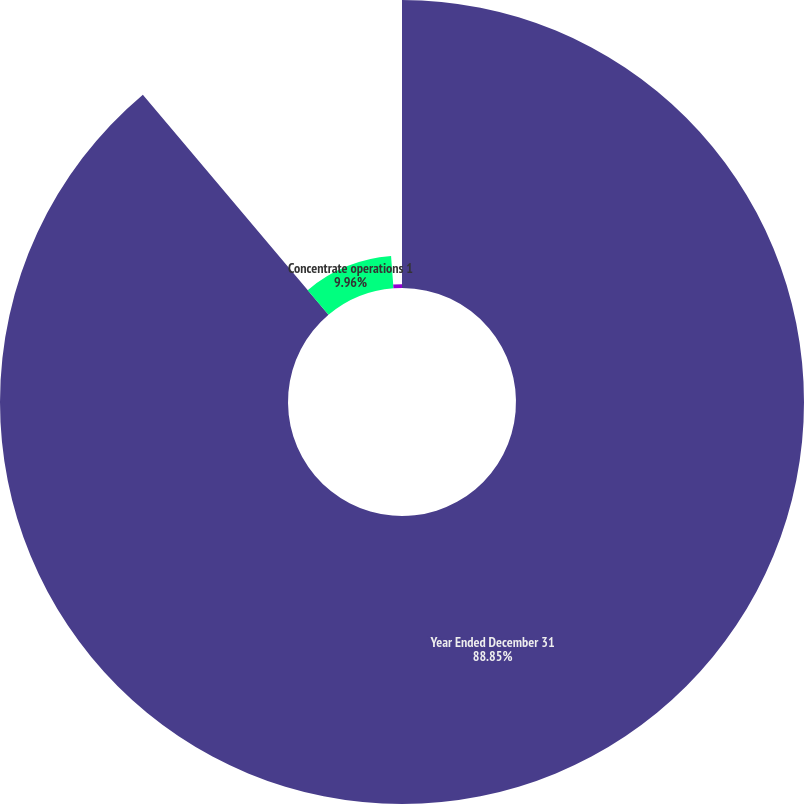Convert chart to OTSL. <chart><loc_0><loc_0><loc_500><loc_500><pie_chart><fcel>Year Ended December 31<fcel>Concentrate operations 1<fcel>Finished product operations 2<nl><fcel>88.85%<fcel>9.96%<fcel>1.19%<nl></chart> 